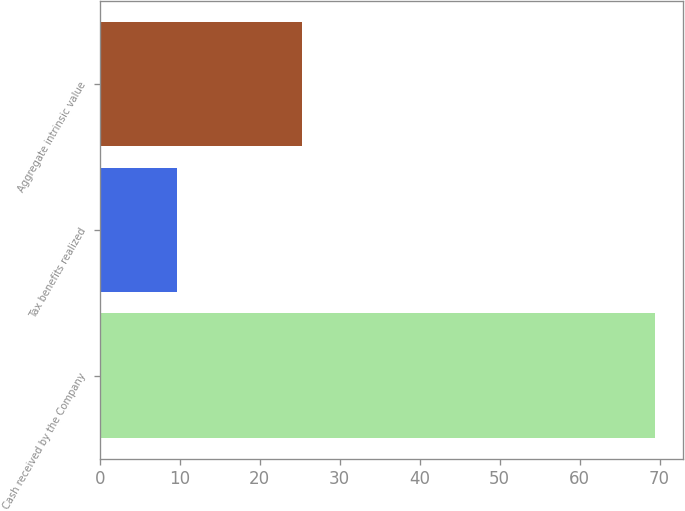<chart> <loc_0><loc_0><loc_500><loc_500><bar_chart><fcel>Cash received by the Company<fcel>Tax benefits realized<fcel>Aggregate intrinsic value<nl><fcel>69.4<fcel>9.7<fcel>25.3<nl></chart> 